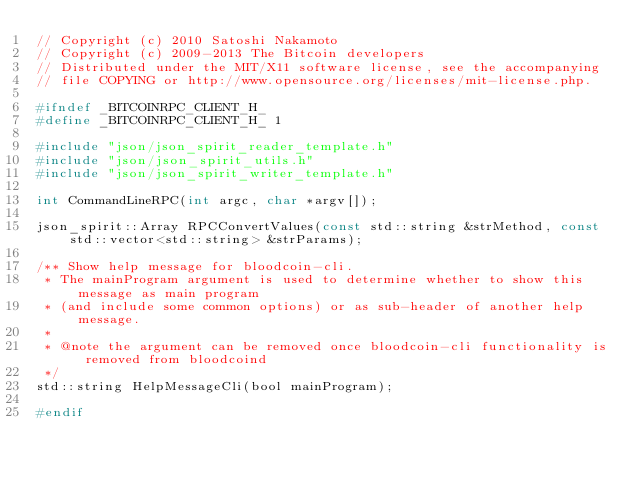Convert code to text. <code><loc_0><loc_0><loc_500><loc_500><_C_>// Copyright (c) 2010 Satoshi Nakamoto
// Copyright (c) 2009-2013 The Bitcoin developers
// Distributed under the MIT/X11 software license, see the accompanying
// file COPYING or http://www.opensource.org/licenses/mit-license.php.

#ifndef _BITCOINRPC_CLIENT_H_
#define _BITCOINRPC_CLIENT_H_ 1

#include "json/json_spirit_reader_template.h"
#include "json/json_spirit_utils.h"
#include "json/json_spirit_writer_template.h"

int CommandLineRPC(int argc, char *argv[]);

json_spirit::Array RPCConvertValues(const std::string &strMethod, const std::vector<std::string> &strParams);

/** Show help message for bloodcoin-cli.
 * The mainProgram argument is used to determine whether to show this message as main program
 * (and include some common options) or as sub-header of another help message.
 *
 * @note the argument can be removed once bloodcoin-cli functionality is removed from bloodcoind
 */
std::string HelpMessageCli(bool mainProgram);

#endif
</code> 